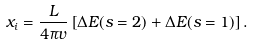<formula> <loc_0><loc_0><loc_500><loc_500>x _ { i } = \frac { L } { 4 \pi v } \left [ \Delta E ( s = 2 ) + \Delta E ( s = 1 ) \right ] .</formula> 